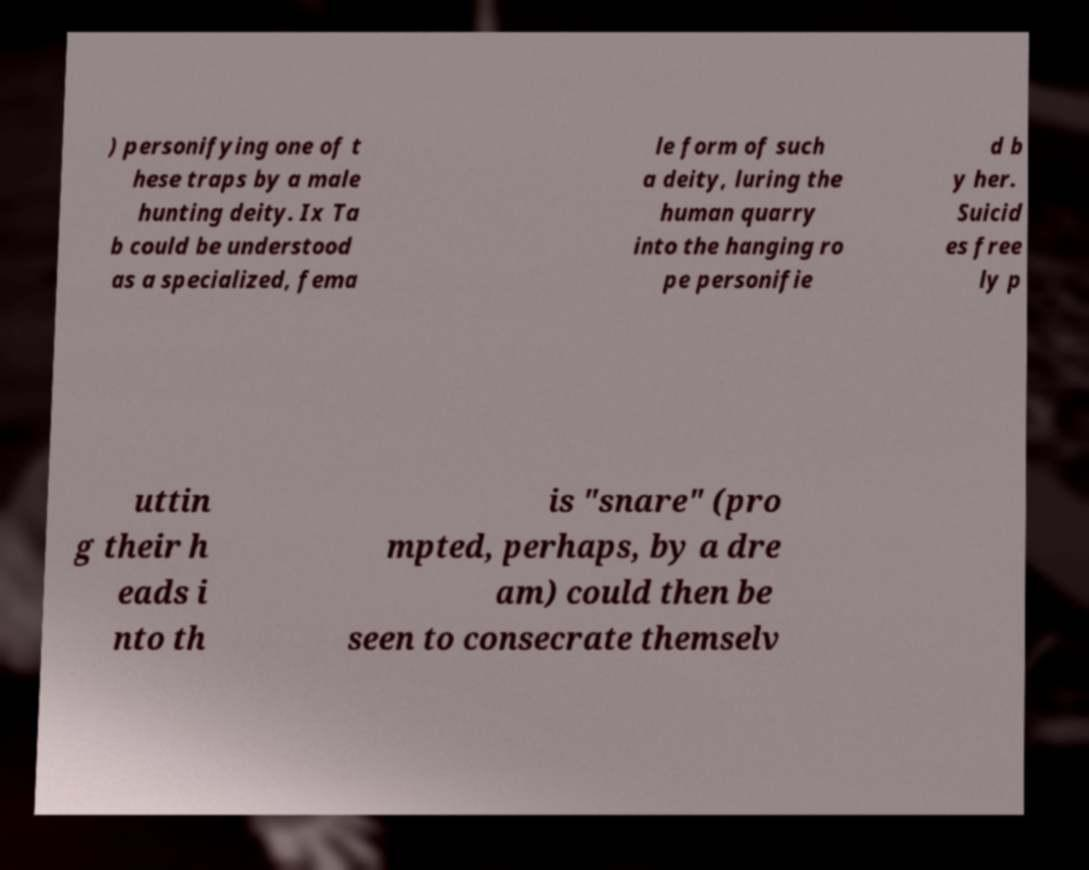For documentation purposes, I need the text within this image transcribed. Could you provide that? ) personifying one of t hese traps by a male hunting deity. Ix Ta b could be understood as a specialized, fema le form of such a deity, luring the human quarry into the hanging ro pe personifie d b y her. Suicid es free ly p uttin g their h eads i nto th is "snare" (pro mpted, perhaps, by a dre am) could then be seen to consecrate themselv 